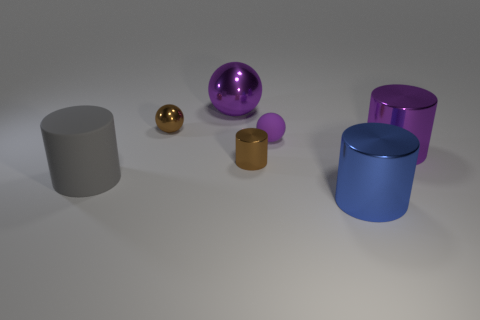The other rubber ball that is the same color as the large ball is what size?
Your response must be concise. Small. What number of large shiny things are in front of the small rubber object and behind the big blue object?
Offer a very short reply. 1. There is a tiny metallic thing that is the same color as the tiny cylinder; what is its shape?
Your answer should be very brief. Sphere. Is there anything else that has the same material as the tiny brown cylinder?
Provide a succinct answer. Yes. Is the material of the big purple cylinder the same as the gray cylinder?
Provide a succinct answer. No. What shape is the big purple shiny object that is on the right side of the brown object in front of the big shiny cylinder that is behind the blue object?
Your answer should be compact. Cylinder. Are there fewer big spheres in front of the brown metallic cylinder than cylinders that are on the left side of the blue metal cylinder?
Keep it short and to the point. Yes. What shape is the large purple object that is on the left side of the big purple metallic thing right of the big blue object?
Provide a succinct answer. Sphere. Is there anything else that has the same color as the small metallic cylinder?
Your answer should be compact. Yes. Is the color of the large ball the same as the rubber ball?
Your answer should be very brief. Yes. 